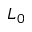<formula> <loc_0><loc_0><loc_500><loc_500>L _ { 0 }</formula> 